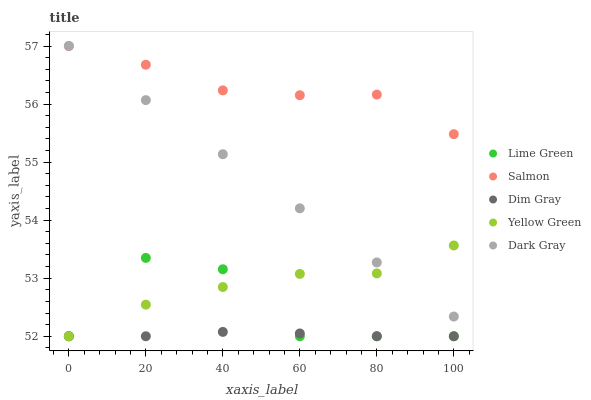Does Dim Gray have the minimum area under the curve?
Answer yes or no. Yes. Does Salmon have the maximum area under the curve?
Answer yes or no. Yes. Does Salmon have the minimum area under the curve?
Answer yes or no. No. Does Dim Gray have the maximum area under the curve?
Answer yes or no. No. Is Dark Gray the smoothest?
Answer yes or no. Yes. Is Lime Green the roughest?
Answer yes or no. Yes. Is Salmon the smoothest?
Answer yes or no. No. Is Salmon the roughest?
Answer yes or no. No. Does Dim Gray have the lowest value?
Answer yes or no. Yes. Does Salmon have the lowest value?
Answer yes or no. No. Does Salmon have the highest value?
Answer yes or no. Yes. Does Dim Gray have the highest value?
Answer yes or no. No. Is Lime Green less than Dark Gray?
Answer yes or no. Yes. Is Dark Gray greater than Dim Gray?
Answer yes or no. Yes. Does Yellow Green intersect Lime Green?
Answer yes or no. Yes. Is Yellow Green less than Lime Green?
Answer yes or no. No. Is Yellow Green greater than Lime Green?
Answer yes or no. No. Does Lime Green intersect Dark Gray?
Answer yes or no. No. 